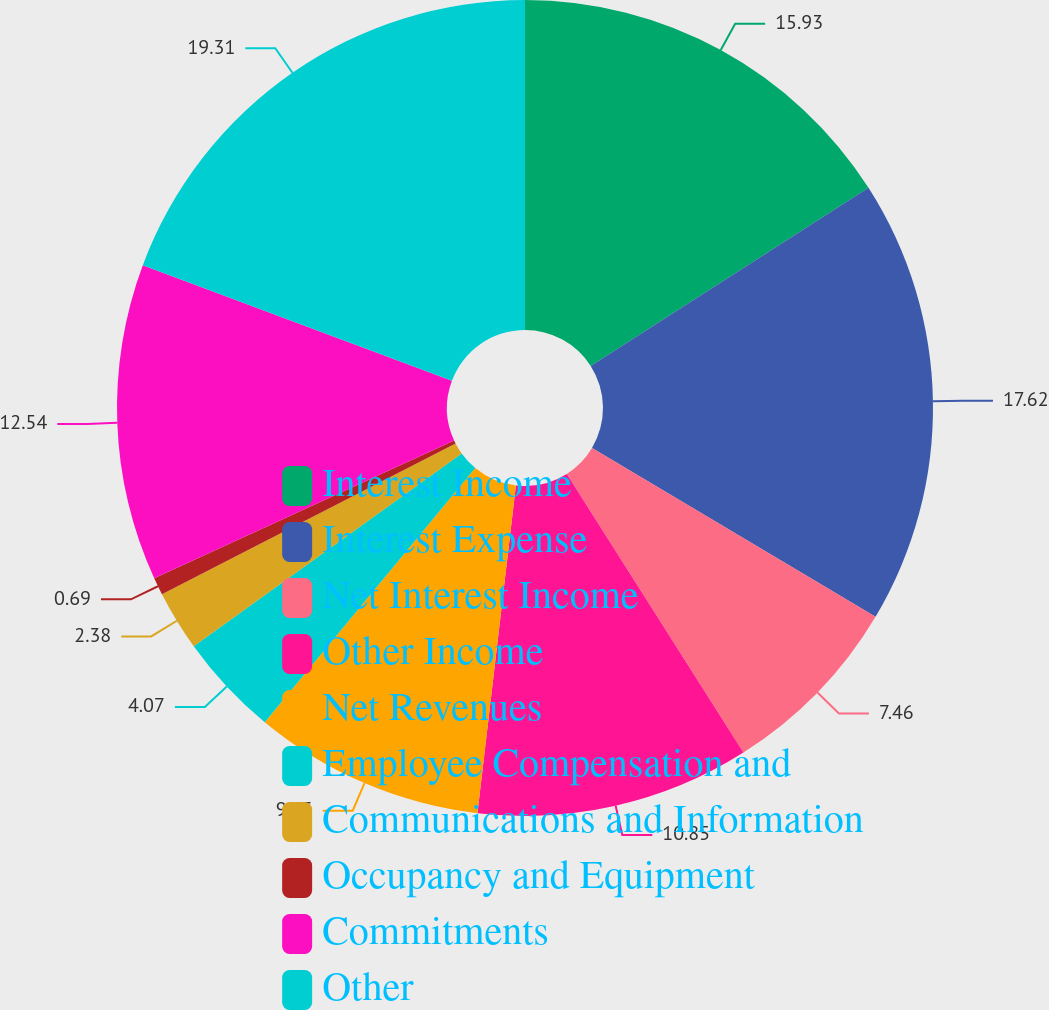<chart> <loc_0><loc_0><loc_500><loc_500><pie_chart><fcel>Interest Income<fcel>Interest Expense<fcel>Net Interest Income<fcel>Other Income<fcel>Net Revenues<fcel>Employee Compensation and<fcel>Communications and Information<fcel>Occupancy and Equipment<fcel>Commitments<fcel>Other<nl><fcel>15.93%<fcel>17.62%<fcel>7.46%<fcel>10.85%<fcel>9.15%<fcel>4.07%<fcel>2.38%<fcel>0.69%<fcel>12.54%<fcel>19.31%<nl></chart> 